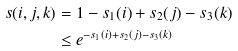Convert formula to latex. <formula><loc_0><loc_0><loc_500><loc_500>s ( i , j , k ) & = 1 - s _ { 1 } ( i ) + s _ { 2 } ( j ) - s _ { 3 } ( k ) \\ & \leq e ^ { - s _ { 1 } ( i ) + s _ { 2 } ( j ) - s _ { 3 } ( k ) }</formula> 